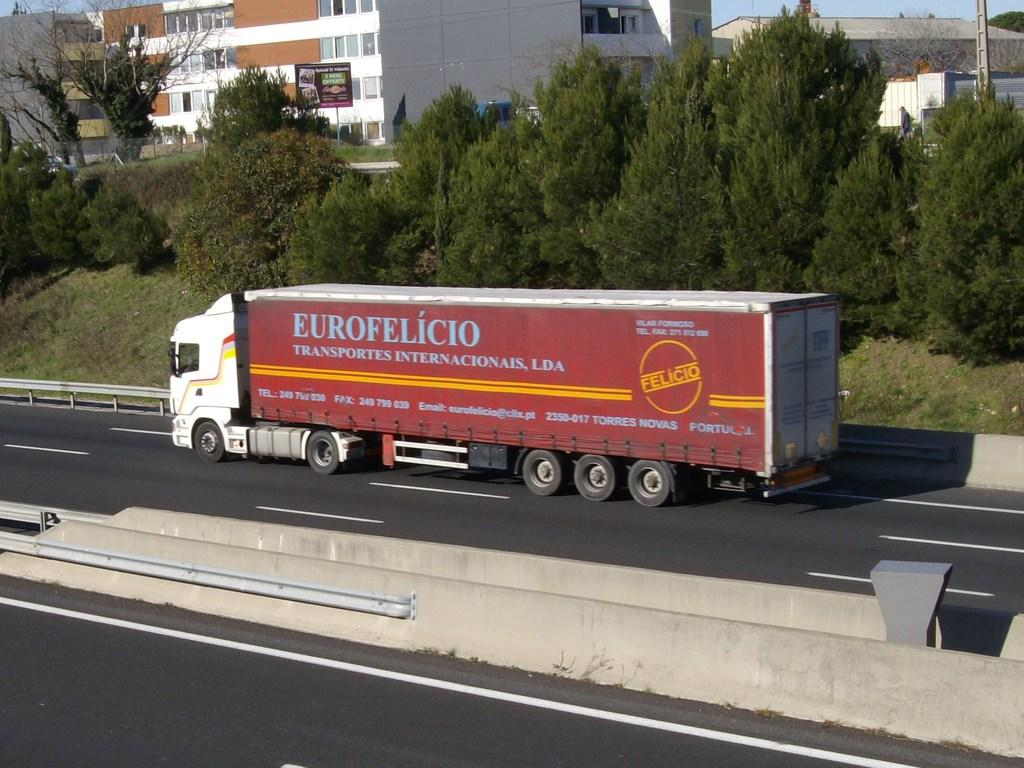What type of structures can be seen in the image? There are buildings in the image. What other natural elements are present in the image? There are trees in the image. What mode of transportation is visible in the image? A truck is moving on the road in the image. What type of signage is present in the image? There is an advertisement board with text in the image. What type of pen is being used to write on the advertisement board in the image? There is no pen visible in the image, and the advertisement board does not appear to have any writing on it. 